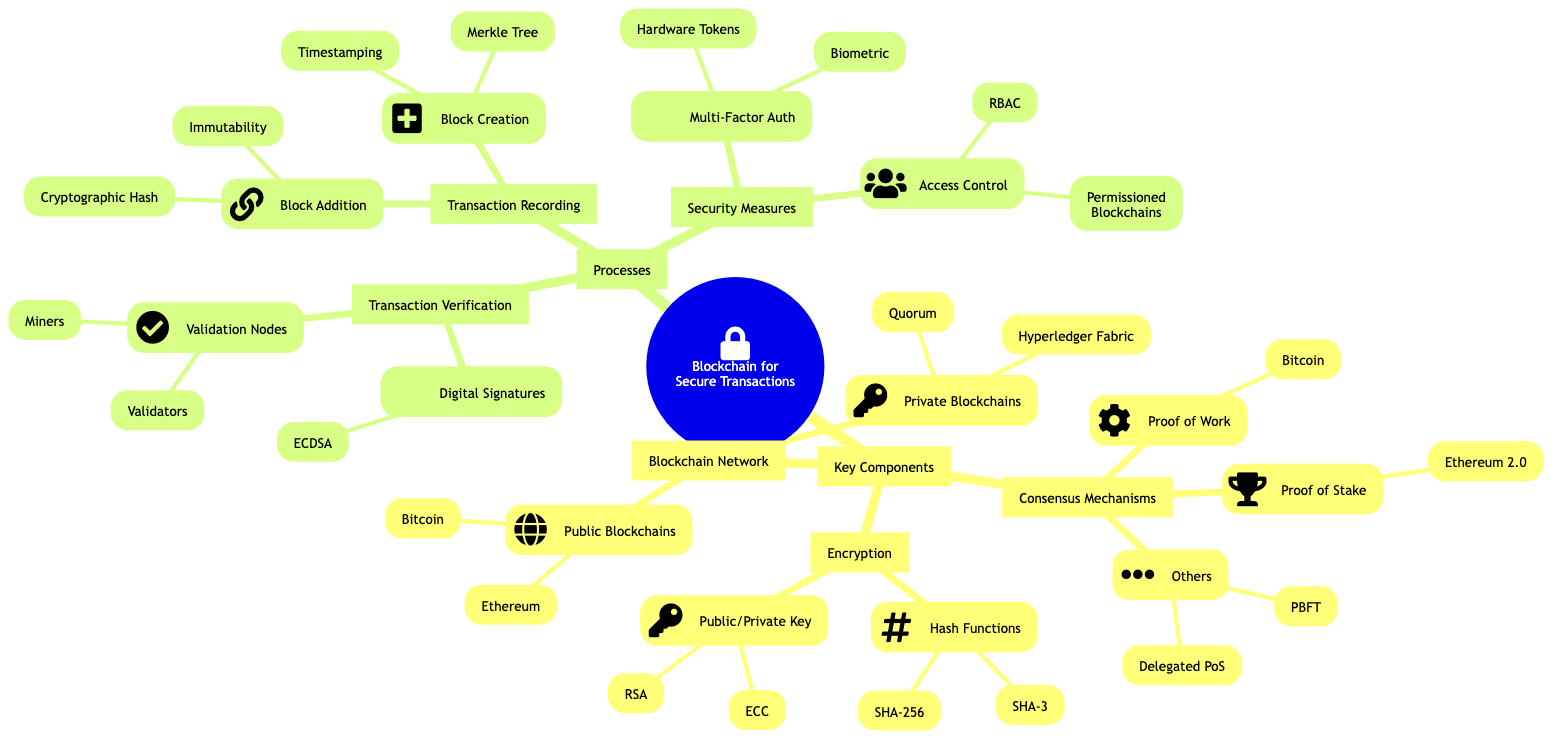What are the examples of public blockchains? The diagram specifically lists Bitcoin and Ethereum under the "Public Blockchains" node.
Answer: Bitcoin, Ethereum What are the examples of private blockchains? The diagram shows Hyperledger Fabric and Quorum as examples in the "Private Blockchains" section.
Answer: Hyperledger Fabric, Quorum How many consensus mechanisms are mentioned in the diagram? The diagram indicates three main types under "Consensus Mechanisms": Proof of Work, Proof of Stake, and Others, totaling three.
Answer: 3 What is the purpose of a Merkle Tree in transaction recording? The diagram identifies Merkle Tree as part of the "Block Creation" process, highlighting its role in the data structure for organizing transactions.
Answer: Data Structure What are the two forms of cryptography mentioned? The diagram states that the two forms of cryptography included are Hash Functions and Public/Private Key Cryptography.
Answer: Hash Functions, Public/Private Key Cryptography What security measure involves biometric verification? The diagram categorizes Biometric Verification under the "Multi-Factor Authentication" security measure, indicating its role in enhancing transaction security.
Answer: Multi-Factor Authentication What nodes are responsible for transaction validation? The "Validation Nodes" in the diagram list Miners and Validators as the entities responsible for this activity.
Answer: Miners, Validators How does the diagram describe the linking of blocks? The diagram indicates that blocks are linked through a Cryptographic Hash, demonstrating how blocks maintain their integrity in the blockchain.
Answer: Cryptographic Hash What is the purpose of digital signatures in transaction verification? Digital Signatures, as noted in the diagram, are aimed at ensuring authenticity and integrity of the transactions, specifically mentioned as ECDSA.
Answer: Authenticity and Integrity 